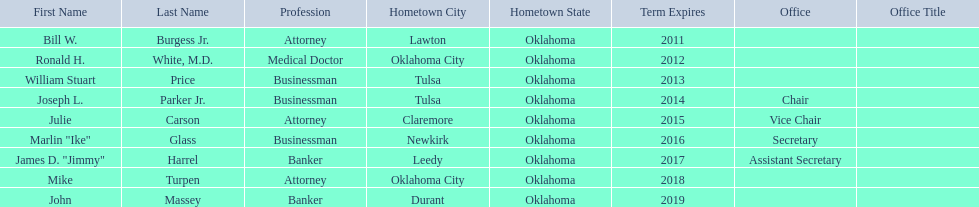Who are the state regents? Bill W. Burgess Jr., Ronald H. White, M.D., William Stuart Price, Joseph L. Parker Jr., Julie Carson, Marlin "Ike" Glass, James D. "Jimmy" Harrel, Mike Turpen, John Massey. Of those state regents, who is from the same hometown as ronald h. white, m.d.? Mike Turpen. 